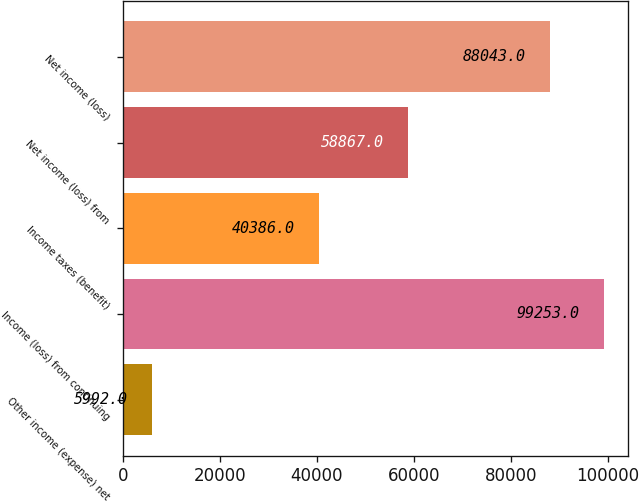Convert chart to OTSL. <chart><loc_0><loc_0><loc_500><loc_500><bar_chart><fcel>Other income (expense) net<fcel>Income (loss) from continuing<fcel>Income taxes (benefit)<fcel>Net income (loss) from<fcel>Net income (loss)<nl><fcel>5992<fcel>99253<fcel>40386<fcel>58867<fcel>88043<nl></chart> 